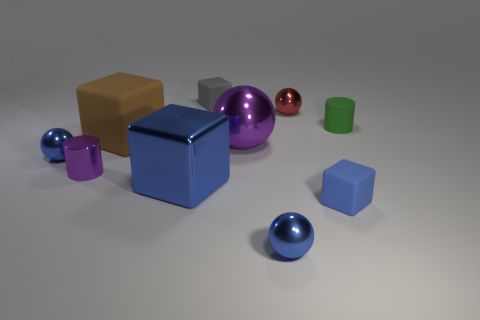There is a blue cube that is to the left of the red metal sphere; how big is it?
Your answer should be very brief. Large. There is a tiny block in front of the tiny gray rubber thing; are there any blocks behind it?
Provide a succinct answer. Yes. Is the material of the tiny blue thing that is on the left side of the big brown cube the same as the red ball?
Give a very brief answer. Yes. What number of small blue things are on the right side of the gray object and on the left side of the brown matte thing?
Your response must be concise. 0. How many cyan objects are made of the same material as the red thing?
Provide a succinct answer. 0. There is a block that is the same material as the small red thing; what color is it?
Make the answer very short. Blue. Is the number of red objects less than the number of large green rubber balls?
Give a very brief answer. No. What is the material of the blue ball that is behind the small blue ball on the right side of the small blue thing left of the large blue shiny object?
Your response must be concise. Metal. What is the green cylinder made of?
Your answer should be very brief. Rubber. There is a rubber cube that is in front of the big rubber block; does it have the same color as the shiny ball that is in front of the tiny blue block?
Give a very brief answer. Yes. 